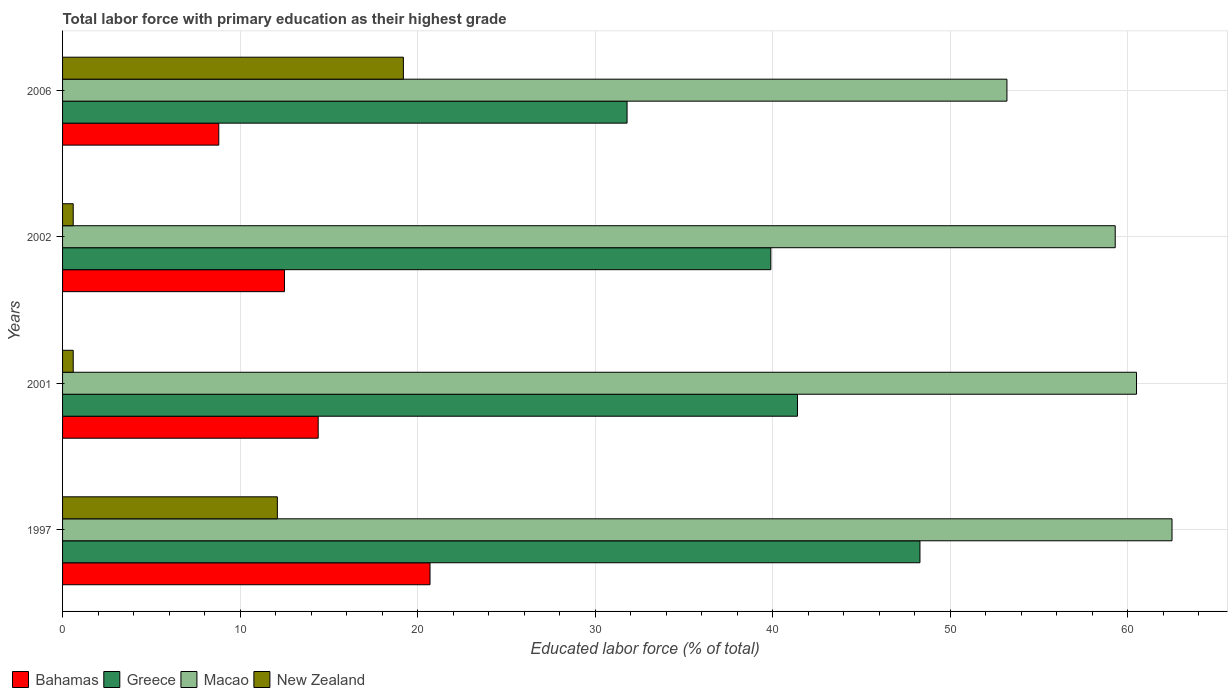How many different coloured bars are there?
Ensure brevity in your answer.  4. How many groups of bars are there?
Offer a terse response. 4. Are the number of bars on each tick of the Y-axis equal?
Offer a terse response. Yes. How many bars are there on the 4th tick from the bottom?
Your answer should be very brief. 4. What is the label of the 4th group of bars from the top?
Your response must be concise. 1997. What is the percentage of total labor force with primary education in Greece in 1997?
Offer a very short reply. 48.3. Across all years, what is the maximum percentage of total labor force with primary education in Macao?
Offer a terse response. 62.5. Across all years, what is the minimum percentage of total labor force with primary education in New Zealand?
Provide a short and direct response. 0.6. In which year was the percentage of total labor force with primary education in Bahamas maximum?
Provide a succinct answer. 1997. What is the total percentage of total labor force with primary education in New Zealand in the graph?
Your answer should be compact. 32.5. What is the difference between the percentage of total labor force with primary education in Bahamas in 1997 and that in 2006?
Provide a short and direct response. 11.9. What is the difference between the percentage of total labor force with primary education in New Zealand in 1997 and the percentage of total labor force with primary education in Greece in 2001?
Provide a short and direct response. -29.3. What is the average percentage of total labor force with primary education in Macao per year?
Make the answer very short. 58.88. In the year 2006, what is the difference between the percentage of total labor force with primary education in Greece and percentage of total labor force with primary education in New Zealand?
Ensure brevity in your answer.  12.6. What is the ratio of the percentage of total labor force with primary education in Greece in 1997 to that in 2001?
Offer a terse response. 1.17. What is the difference between the highest and the lowest percentage of total labor force with primary education in Bahamas?
Offer a terse response. 11.9. What does the 4th bar from the top in 1997 represents?
Offer a terse response. Bahamas. What does the 4th bar from the bottom in 2006 represents?
Provide a succinct answer. New Zealand. Are the values on the major ticks of X-axis written in scientific E-notation?
Ensure brevity in your answer.  No. Does the graph contain any zero values?
Your response must be concise. No. Does the graph contain grids?
Provide a succinct answer. Yes. How many legend labels are there?
Offer a very short reply. 4. What is the title of the graph?
Give a very brief answer. Total labor force with primary education as their highest grade. Does "Iceland" appear as one of the legend labels in the graph?
Offer a very short reply. No. What is the label or title of the X-axis?
Keep it short and to the point. Educated labor force (% of total). What is the Educated labor force (% of total) of Bahamas in 1997?
Keep it short and to the point. 20.7. What is the Educated labor force (% of total) of Greece in 1997?
Keep it short and to the point. 48.3. What is the Educated labor force (% of total) in Macao in 1997?
Your answer should be compact. 62.5. What is the Educated labor force (% of total) of New Zealand in 1997?
Provide a short and direct response. 12.1. What is the Educated labor force (% of total) in Bahamas in 2001?
Your answer should be very brief. 14.4. What is the Educated labor force (% of total) in Greece in 2001?
Your answer should be very brief. 41.4. What is the Educated labor force (% of total) in Macao in 2001?
Your answer should be compact. 60.5. What is the Educated labor force (% of total) in New Zealand in 2001?
Make the answer very short. 0.6. What is the Educated labor force (% of total) in Greece in 2002?
Keep it short and to the point. 39.9. What is the Educated labor force (% of total) of Macao in 2002?
Provide a succinct answer. 59.3. What is the Educated labor force (% of total) of New Zealand in 2002?
Ensure brevity in your answer.  0.6. What is the Educated labor force (% of total) of Bahamas in 2006?
Offer a terse response. 8.8. What is the Educated labor force (% of total) in Greece in 2006?
Ensure brevity in your answer.  31.8. What is the Educated labor force (% of total) of Macao in 2006?
Provide a succinct answer. 53.2. What is the Educated labor force (% of total) of New Zealand in 2006?
Keep it short and to the point. 19.2. Across all years, what is the maximum Educated labor force (% of total) in Bahamas?
Offer a terse response. 20.7. Across all years, what is the maximum Educated labor force (% of total) in Greece?
Offer a very short reply. 48.3. Across all years, what is the maximum Educated labor force (% of total) of Macao?
Offer a very short reply. 62.5. Across all years, what is the maximum Educated labor force (% of total) of New Zealand?
Your answer should be compact. 19.2. Across all years, what is the minimum Educated labor force (% of total) in Bahamas?
Offer a very short reply. 8.8. Across all years, what is the minimum Educated labor force (% of total) in Greece?
Your answer should be compact. 31.8. Across all years, what is the minimum Educated labor force (% of total) of Macao?
Provide a succinct answer. 53.2. Across all years, what is the minimum Educated labor force (% of total) of New Zealand?
Your answer should be very brief. 0.6. What is the total Educated labor force (% of total) in Bahamas in the graph?
Your answer should be compact. 56.4. What is the total Educated labor force (% of total) of Greece in the graph?
Provide a succinct answer. 161.4. What is the total Educated labor force (% of total) of Macao in the graph?
Provide a succinct answer. 235.5. What is the total Educated labor force (% of total) in New Zealand in the graph?
Provide a succinct answer. 32.5. What is the difference between the Educated labor force (% of total) in New Zealand in 1997 and that in 2001?
Make the answer very short. 11.5. What is the difference between the Educated labor force (% of total) in Bahamas in 1997 and that in 2002?
Provide a succinct answer. 8.2. What is the difference between the Educated labor force (% of total) of Greece in 1997 and that in 2002?
Provide a short and direct response. 8.4. What is the difference between the Educated labor force (% of total) in New Zealand in 1997 and that in 2002?
Ensure brevity in your answer.  11.5. What is the difference between the Educated labor force (% of total) in New Zealand in 1997 and that in 2006?
Offer a very short reply. -7.1. What is the difference between the Educated labor force (% of total) of Bahamas in 2001 and that in 2002?
Your response must be concise. 1.9. What is the difference between the Educated labor force (% of total) of Macao in 2001 and that in 2002?
Make the answer very short. 1.2. What is the difference between the Educated labor force (% of total) in Greece in 2001 and that in 2006?
Offer a terse response. 9.6. What is the difference between the Educated labor force (% of total) of New Zealand in 2001 and that in 2006?
Your answer should be compact. -18.6. What is the difference between the Educated labor force (% of total) of Macao in 2002 and that in 2006?
Make the answer very short. 6.1. What is the difference between the Educated labor force (% of total) in New Zealand in 2002 and that in 2006?
Provide a succinct answer. -18.6. What is the difference between the Educated labor force (% of total) in Bahamas in 1997 and the Educated labor force (% of total) in Greece in 2001?
Give a very brief answer. -20.7. What is the difference between the Educated labor force (% of total) in Bahamas in 1997 and the Educated labor force (% of total) in Macao in 2001?
Your response must be concise. -39.8. What is the difference between the Educated labor force (% of total) of Bahamas in 1997 and the Educated labor force (% of total) of New Zealand in 2001?
Provide a short and direct response. 20.1. What is the difference between the Educated labor force (% of total) in Greece in 1997 and the Educated labor force (% of total) in New Zealand in 2001?
Your answer should be very brief. 47.7. What is the difference between the Educated labor force (% of total) of Macao in 1997 and the Educated labor force (% of total) of New Zealand in 2001?
Keep it short and to the point. 61.9. What is the difference between the Educated labor force (% of total) of Bahamas in 1997 and the Educated labor force (% of total) of Greece in 2002?
Ensure brevity in your answer.  -19.2. What is the difference between the Educated labor force (% of total) of Bahamas in 1997 and the Educated labor force (% of total) of Macao in 2002?
Your response must be concise. -38.6. What is the difference between the Educated labor force (% of total) in Bahamas in 1997 and the Educated labor force (% of total) in New Zealand in 2002?
Provide a short and direct response. 20.1. What is the difference between the Educated labor force (% of total) of Greece in 1997 and the Educated labor force (% of total) of Macao in 2002?
Offer a terse response. -11. What is the difference between the Educated labor force (% of total) of Greece in 1997 and the Educated labor force (% of total) of New Zealand in 2002?
Ensure brevity in your answer.  47.7. What is the difference between the Educated labor force (% of total) in Macao in 1997 and the Educated labor force (% of total) in New Zealand in 2002?
Your answer should be very brief. 61.9. What is the difference between the Educated labor force (% of total) in Bahamas in 1997 and the Educated labor force (% of total) in Macao in 2006?
Provide a succinct answer. -32.5. What is the difference between the Educated labor force (% of total) in Greece in 1997 and the Educated labor force (% of total) in New Zealand in 2006?
Keep it short and to the point. 29.1. What is the difference between the Educated labor force (% of total) of Macao in 1997 and the Educated labor force (% of total) of New Zealand in 2006?
Provide a short and direct response. 43.3. What is the difference between the Educated labor force (% of total) of Bahamas in 2001 and the Educated labor force (% of total) of Greece in 2002?
Your answer should be compact. -25.5. What is the difference between the Educated labor force (% of total) in Bahamas in 2001 and the Educated labor force (% of total) in Macao in 2002?
Provide a succinct answer. -44.9. What is the difference between the Educated labor force (% of total) of Greece in 2001 and the Educated labor force (% of total) of Macao in 2002?
Ensure brevity in your answer.  -17.9. What is the difference between the Educated labor force (% of total) in Greece in 2001 and the Educated labor force (% of total) in New Zealand in 2002?
Your answer should be very brief. 40.8. What is the difference between the Educated labor force (% of total) in Macao in 2001 and the Educated labor force (% of total) in New Zealand in 2002?
Provide a succinct answer. 59.9. What is the difference between the Educated labor force (% of total) in Bahamas in 2001 and the Educated labor force (% of total) in Greece in 2006?
Offer a terse response. -17.4. What is the difference between the Educated labor force (% of total) of Bahamas in 2001 and the Educated labor force (% of total) of Macao in 2006?
Offer a terse response. -38.8. What is the difference between the Educated labor force (% of total) of Bahamas in 2001 and the Educated labor force (% of total) of New Zealand in 2006?
Your answer should be very brief. -4.8. What is the difference between the Educated labor force (% of total) in Macao in 2001 and the Educated labor force (% of total) in New Zealand in 2006?
Your response must be concise. 41.3. What is the difference between the Educated labor force (% of total) of Bahamas in 2002 and the Educated labor force (% of total) of Greece in 2006?
Keep it short and to the point. -19.3. What is the difference between the Educated labor force (% of total) of Bahamas in 2002 and the Educated labor force (% of total) of Macao in 2006?
Make the answer very short. -40.7. What is the difference between the Educated labor force (% of total) of Bahamas in 2002 and the Educated labor force (% of total) of New Zealand in 2006?
Your answer should be compact. -6.7. What is the difference between the Educated labor force (% of total) in Greece in 2002 and the Educated labor force (% of total) in New Zealand in 2006?
Keep it short and to the point. 20.7. What is the difference between the Educated labor force (% of total) of Macao in 2002 and the Educated labor force (% of total) of New Zealand in 2006?
Your response must be concise. 40.1. What is the average Educated labor force (% of total) of Bahamas per year?
Your response must be concise. 14.1. What is the average Educated labor force (% of total) of Greece per year?
Keep it short and to the point. 40.35. What is the average Educated labor force (% of total) of Macao per year?
Your answer should be compact. 58.88. What is the average Educated labor force (% of total) in New Zealand per year?
Your answer should be compact. 8.12. In the year 1997, what is the difference between the Educated labor force (% of total) of Bahamas and Educated labor force (% of total) of Greece?
Give a very brief answer. -27.6. In the year 1997, what is the difference between the Educated labor force (% of total) of Bahamas and Educated labor force (% of total) of Macao?
Ensure brevity in your answer.  -41.8. In the year 1997, what is the difference between the Educated labor force (% of total) of Bahamas and Educated labor force (% of total) of New Zealand?
Your answer should be compact. 8.6. In the year 1997, what is the difference between the Educated labor force (% of total) in Greece and Educated labor force (% of total) in New Zealand?
Give a very brief answer. 36.2. In the year 1997, what is the difference between the Educated labor force (% of total) in Macao and Educated labor force (% of total) in New Zealand?
Offer a very short reply. 50.4. In the year 2001, what is the difference between the Educated labor force (% of total) of Bahamas and Educated labor force (% of total) of Macao?
Provide a succinct answer. -46.1. In the year 2001, what is the difference between the Educated labor force (% of total) in Greece and Educated labor force (% of total) in Macao?
Give a very brief answer. -19.1. In the year 2001, what is the difference between the Educated labor force (% of total) in Greece and Educated labor force (% of total) in New Zealand?
Your answer should be compact. 40.8. In the year 2001, what is the difference between the Educated labor force (% of total) in Macao and Educated labor force (% of total) in New Zealand?
Your response must be concise. 59.9. In the year 2002, what is the difference between the Educated labor force (% of total) of Bahamas and Educated labor force (% of total) of Greece?
Make the answer very short. -27.4. In the year 2002, what is the difference between the Educated labor force (% of total) in Bahamas and Educated labor force (% of total) in Macao?
Your response must be concise. -46.8. In the year 2002, what is the difference between the Educated labor force (% of total) of Greece and Educated labor force (% of total) of Macao?
Offer a very short reply. -19.4. In the year 2002, what is the difference between the Educated labor force (% of total) of Greece and Educated labor force (% of total) of New Zealand?
Make the answer very short. 39.3. In the year 2002, what is the difference between the Educated labor force (% of total) of Macao and Educated labor force (% of total) of New Zealand?
Offer a terse response. 58.7. In the year 2006, what is the difference between the Educated labor force (% of total) of Bahamas and Educated labor force (% of total) of Macao?
Keep it short and to the point. -44.4. In the year 2006, what is the difference between the Educated labor force (% of total) in Greece and Educated labor force (% of total) in Macao?
Your answer should be very brief. -21.4. In the year 2006, what is the difference between the Educated labor force (% of total) of Greece and Educated labor force (% of total) of New Zealand?
Offer a terse response. 12.6. In the year 2006, what is the difference between the Educated labor force (% of total) of Macao and Educated labor force (% of total) of New Zealand?
Provide a short and direct response. 34. What is the ratio of the Educated labor force (% of total) of Bahamas in 1997 to that in 2001?
Your response must be concise. 1.44. What is the ratio of the Educated labor force (% of total) in Greece in 1997 to that in 2001?
Ensure brevity in your answer.  1.17. What is the ratio of the Educated labor force (% of total) in Macao in 1997 to that in 2001?
Provide a succinct answer. 1.03. What is the ratio of the Educated labor force (% of total) of New Zealand in 1997 to that in 2001?
Your answer should be very brief. 20.17. What is the ratio of the Educated labor force (% of total) in Bahamas in 1997 to that in 2002?
Your answer should be compact. 1.66. What is the ratio of the Educated labor force (% of total) of Greece in 1997 to that in 2002?
Provide a succinct answer. 1.21. What is the ratio of the Educated labor force (% of total) of Macao in 1997 to that in 2002?
Give a very brief answer. 1.05. What is the ratio of the Educated labor force (% of total) of New Zealand in 1997 to that in 2002?
Your answer should be compact. 20.17. What is the ratio of the Educated labor force (% of total) of Bahamas in 1997 to that in 2006?
Keep it short and to the point. 2.35. What is the ratio of the Educated labor force (% of total) in Greece in 1997 to that in 2006?
Keep it short and to the point. 1.52. What is the ratio of the Educated labor force (% of total) of Macao in 1997 to that in 2006?
Keep it short and to the point. 1.17. What is the ratio of the Educated labor force (% of total) of New Zealand in 1997 to that in 2006?
Provide a short and direct response. 0.63. What is the ratio of the Educated labor force (% of total) in Bahamas in 2001 to that in 2002?
Give a very brief answer. 1.15. What is the ratio of the Educated labor force (% of total) of Greece in 2001 to that in 2002?
Give a very brief answer. 1.04. What is the ratio of the Educated labor force (% of total) of Macao in 2001 to that in 2002?
Your answer should be very brief. 1.02. What is the ratio of the Educated labor force (% of total) in Bahamas in 2001 to that in 2006?
Provide a succinct answer. 1.64. What is the ratio of the Educated labor force (% of total) in Greece in 2001 to that in 2006?
Give a very brief answer. 1.3. What is the ratio of the Educated labor force (% of total) of Macao in 2001 to that in 2006?
Your response must be concise. 1.14. What is the ratio of the Educated labor force (% of total) of New Zealand in 2001 to that in 2006?
Keep it short and to the point. 0.03. What is the ratio of the Educated labor force (% of total) in Bahamas in 2002 to that in 2006?
Provide a succinct answer. 1.42. What is the ratio of the Educated labor force (% of total) in Greece in 2002 to that in 2006?
Your answer should be compact. 1.25. What is the ratio of the Educated labor force (% of total) of Macao in 2002 to that in 2006?
Provide a short and direct response. 1.11. What is the ratio of the Educated labor force (% of total) of New Zealand in 2002 to that in 2006?
Provide a short and direct response. 0.03. What is the difference between the highest and the second highest Educated labor force (% of total) of Bahamas?
Provide a succinct answer. 6.3. What is the difference between the highest and the second highest Educated labor force (% of total) of New Zealand?
Ensure brevity in your answer.  7.1. What is the difference between the highest and the lowest Educated labor force (% of total) of Bahamas?
Offer a terse response. 11.9. What is the difference between the highest and the lowest Educated labor force (% of total) of Greece?
Keep it short and to the point. 16.5. What is the difference between the highest and the lowest Educated labor force (% of total) in Macao?
Your response must be concise. 9.3. 